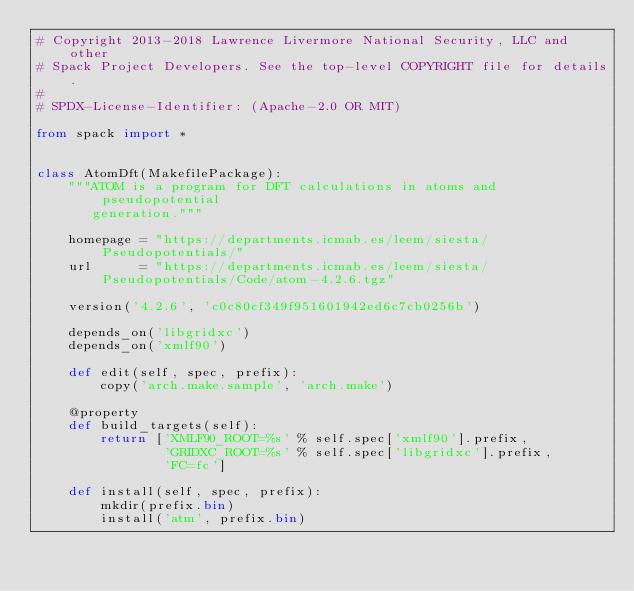Convert code to text. <code><loc_0><loc_0><loc_500><loc_500><_Python_># Copyright 2013-2018 Lawrence Livermore National Security, LLC and other
# Spack Project Developers. See the top-level COPYRIGHT file for details.
#
# SPDX-License-Identifier: (Apache-2.0 OR MIT)

from spack import *


class AtomDft(MakefilePackage):
    """ATOM is a program for DFT calculations in atoms and pseudopotential
       generation."""

    homepage = "https://departments.icmab.es/leem/siesta/Pseudopotentials/"
    url      = "https://departments.icmab.es/leem/siesta/Pseudopotentials/Code/atom-4.2.6.tgz"

    version('4.2.6', 'c0c80cf349f951601942ed6c7cb0256b')

    depends_on('libgridxc')
    depends_on('xmlf90')

    def edit(self, spec, prefix):
        copy('arch.make.sample', 'arch.make')

    @property
    def build_targets(self):
        return ['XMLF90_ROOT=%s' % self.spec['xmlf90'].prefix,
                'GRIDXC_ROOT=%s' % self.spec['libgridxc'].prefix,
                'FC=fc']

    def install(self, spec, prefix):
        mkdir(prefix.bin)
        install('atm', prefix.bin)
</code> 